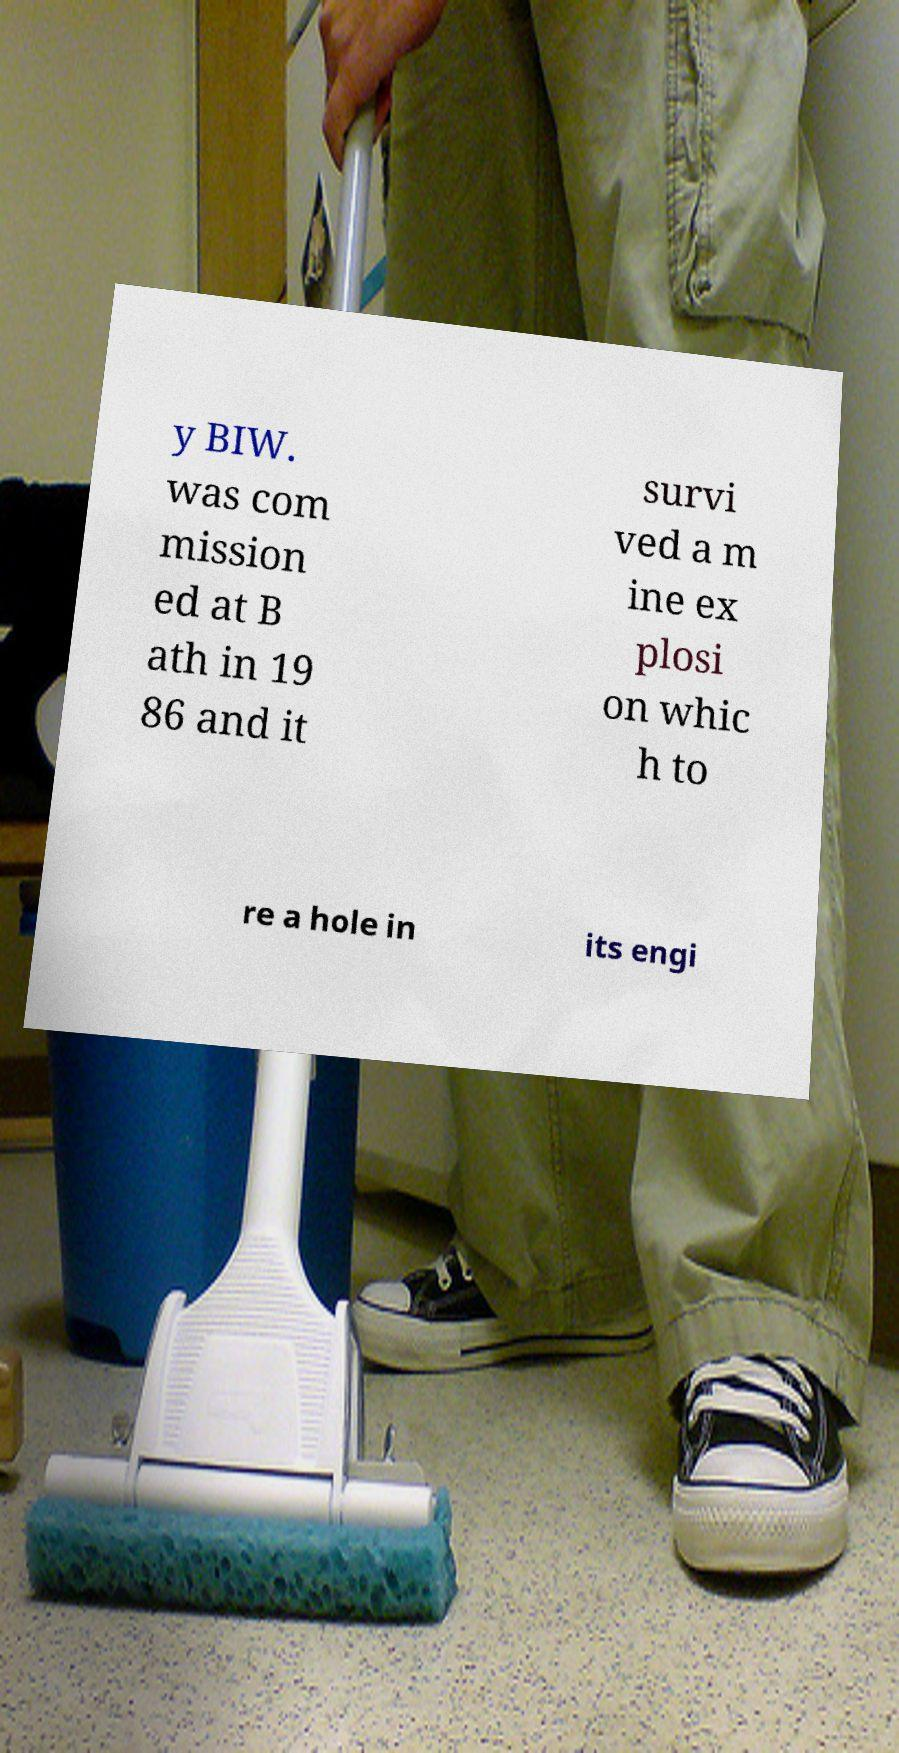Can you accurately transcribe the text from the provided image for me? y BIW. was com mission ed at B ath in 19 86 and it survi ved a m ine ex plosi on whic h to re a hole in its engi 